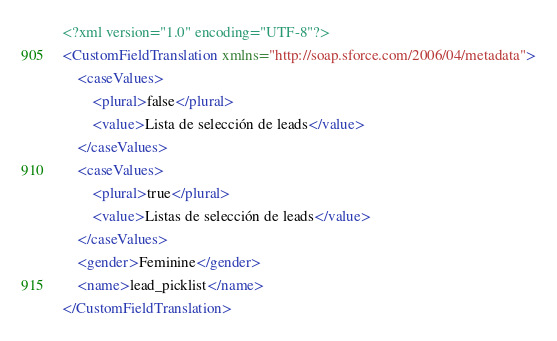<code> <loc_0><loc_0><loc_500><loc_500><_XML_><?xml version="1.0" encoding="UTF-8"?>
<CustomFieldTranslation xmlns="http://soap.sforce.com/2006/04/metadata">
    <caseValues>
        <plural>false</plural>
        <value>Lista de selección de leads</value>
    </caseValues>
    <caseValues>
        <plural>true</plural>
        <value>Listas de selección de leads</value>
    </caseValues>
    <gender>Feminine</gender>
    <name>lead_picklist</name>
</CustomFieldTranslation>
</code> 